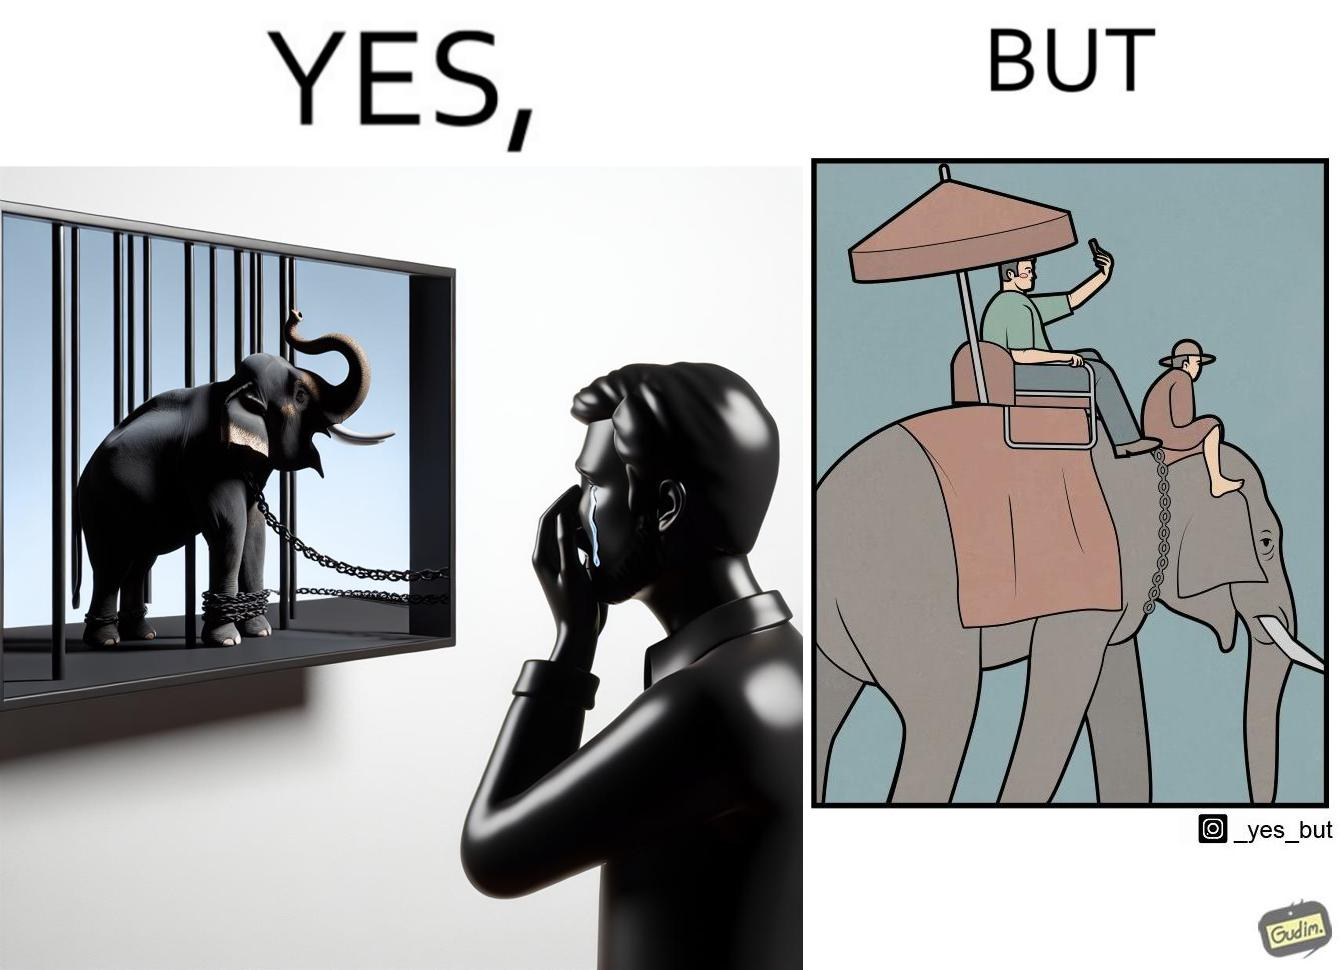What is shown in the left half versus the right half of this image? In the left part of the image: a man crying on seeing an elephant being chained in a cage in a TV program In the right part of the image: a person riding an elephant while taking selfies 